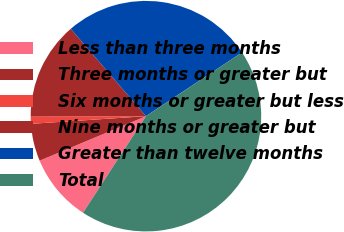Convert chart. <chart><loc_0><loc_0><loc_500><loc_500><pie_chart><fcel>Less than three months<fcel>Three months or greater but<fcel>Six months or greater but less<fcel>Nine months or greater but<fcel>Greater than twelve months<fcel>Total<nl><fcel>9.5%<fcel>5.25%<fcel>1.0%<fcel>13.75%<fcel>26.99%<fcel>43.52%<nl></chart> 